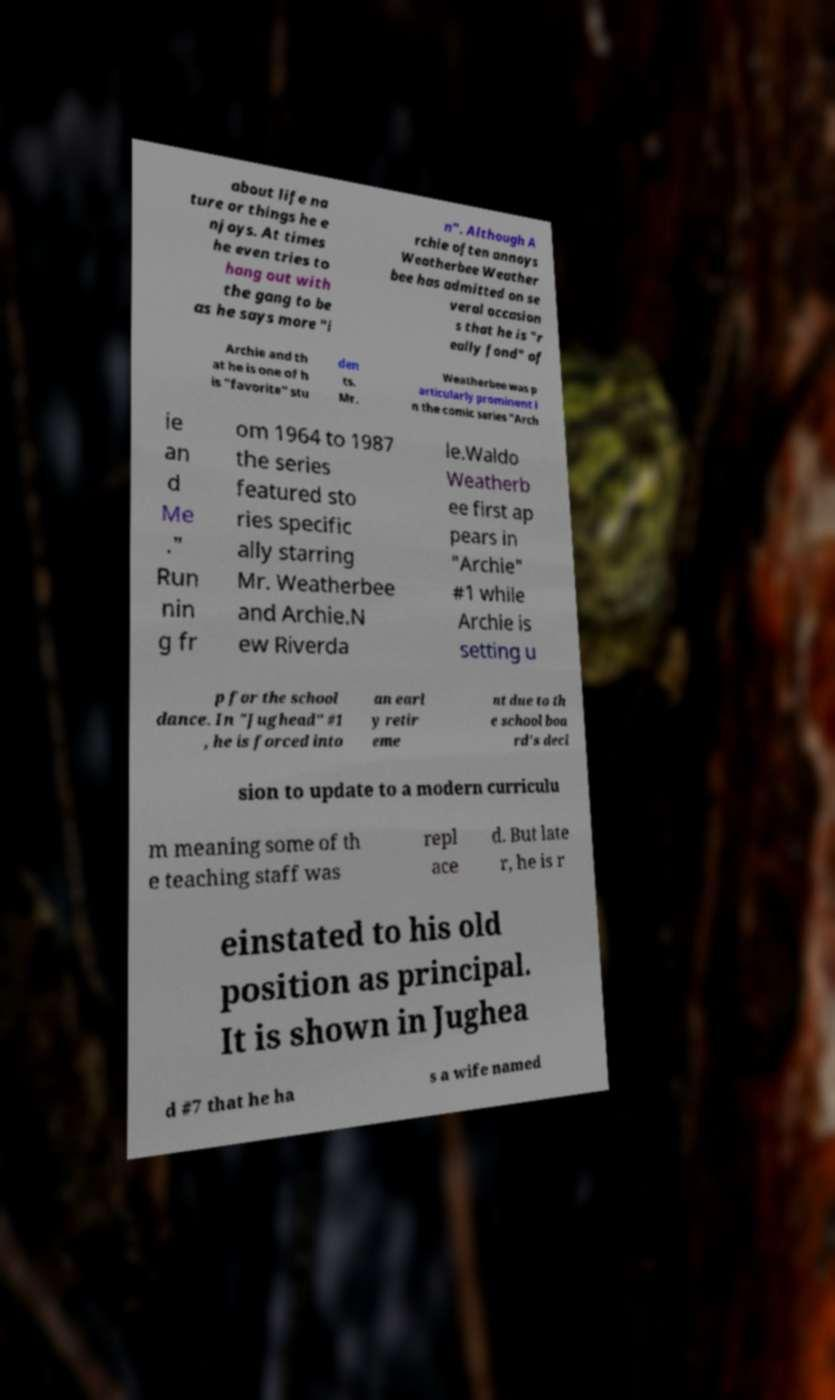For documentation purposes, I need the text within this image transcribed. Could you provide that? about life na ture or things he e njoys. At times he even tries to hang out with the gang to be as he says more "i n". Although A rchie often annoys Weatherbee Weather bee has admitted on se veral occasion s that he is "r eally fond" of Archie and th at he is one of h is "favorite" stu den ts. Mr. Weatherbee was p articularly prominent i n the comic series "Arch ie an d Me ." Run nin g fr om 1964 to 1987 the series featured sto ries specific ally starring Mr. Weatherbee and Archie.N ew Riverda le.Waldo Weatherb ee first ap pears in "Archie" #1 while Archie is setting u p for the school dance. In "Jughead" #1 , he is forced into an earl y retir eme nt due to th e school boa rd's deci sion to update to a modern curriculu m meaning some of th e teaching staff was repl ace d. But late r, he is r einstated to his old position as principal. It is shown in Jughea d #7 that he ha s a wife named 